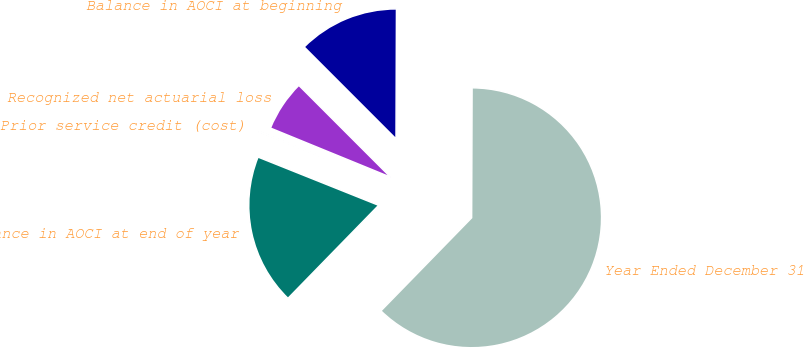<chart> <loc_0><loc_0><loc_500><loc_500><pie_chart><fcel>Year Ended December 31<fcel>Balance in AOCI at beginning<fcel>Recognized net actuarial loss<fcel>Prior service credit (cost)<fcel>Balance in AOCI at end of year<nl><fcel>62.24%<fcel>12.55%<fcel>6.33%<fcel>0.12%<fcel>18.76%<nl></chart> 